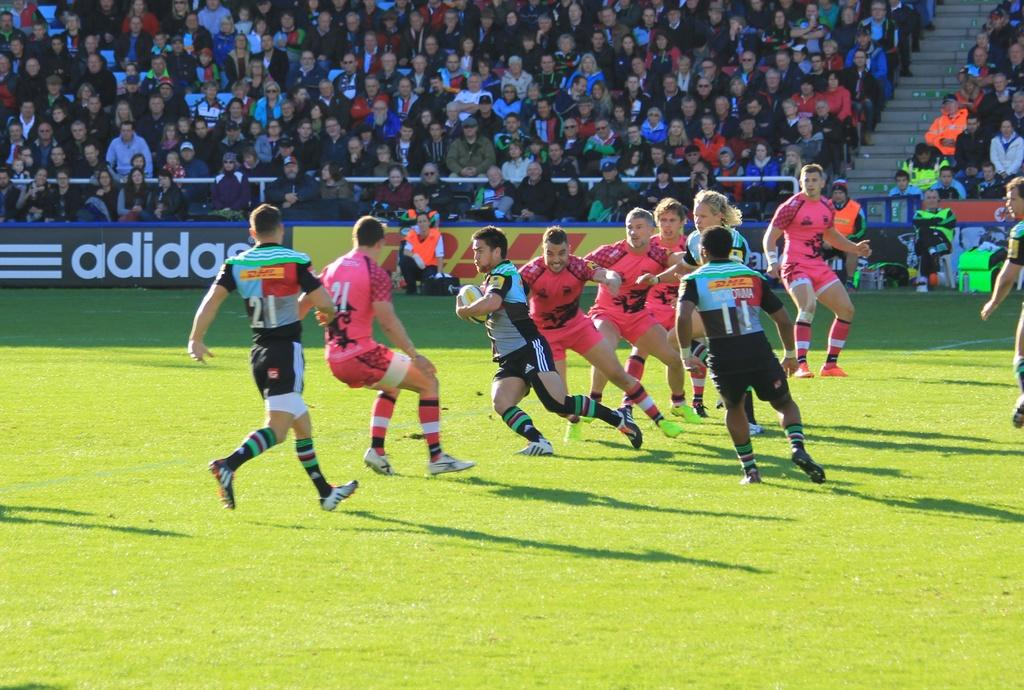<image>
Render a clear and concise summary of the photo. A large crowd watch the action on the pitch as two rugby teams clash in front of a black and white adidas hoarding. 